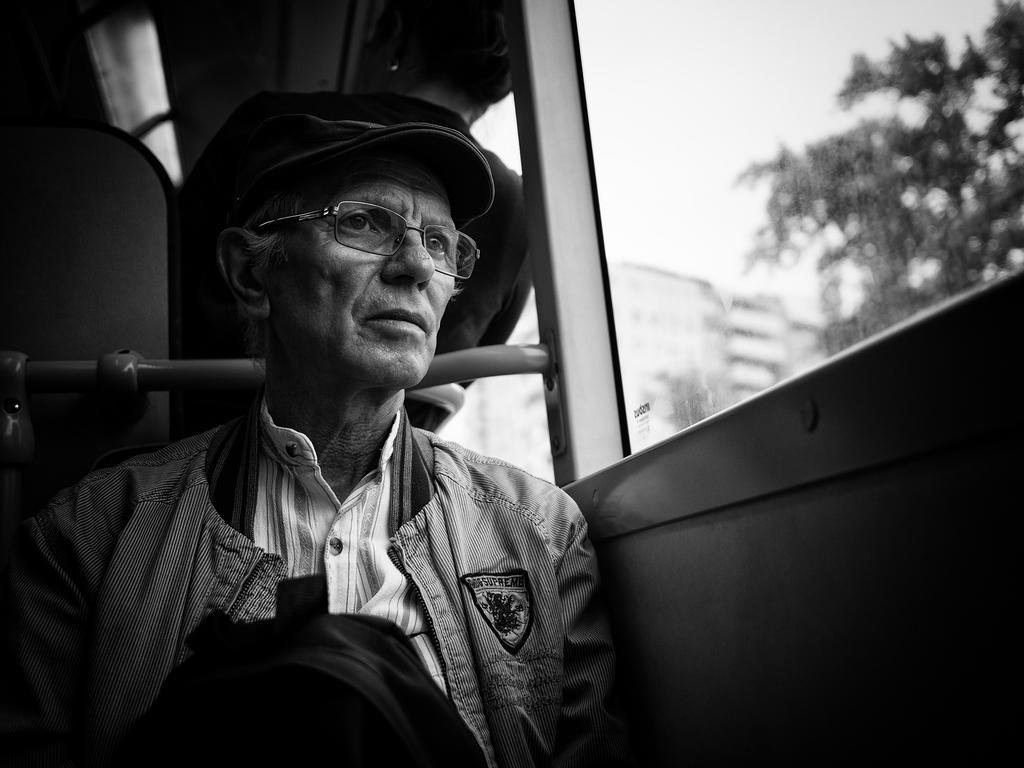In one or two sentences, can you explain what this image depicts? This is a black and white image. In this image, we can see a man is in the vehicle. On the right side, we can see a glass window. In the background, we can see a metal rod and seats. On the left side, we can see a window, outside of the window, we can see some trees and a building. At the top, we can see white color, at the bottom, we can see a bag in the bus. 